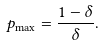<formula> <loc_0><loc_0><loc_500><loc_500>p _ { \max } = \frac { 1 - \delta } { \delta } .</formula> 